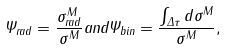Convert formula to latex. <formula><loc_0><loc_0><loc_500><loc_500>\Psi _ { r a d } = \frac { \sigma ^ { M } _ { r a d } } { \sigma ^ { M } } a n d \Psi _ { b i n } = \frac { \int _ { \Delta \tau } d \sigma ^ { M } } { \sigma ^ { M } } ,</formula> 